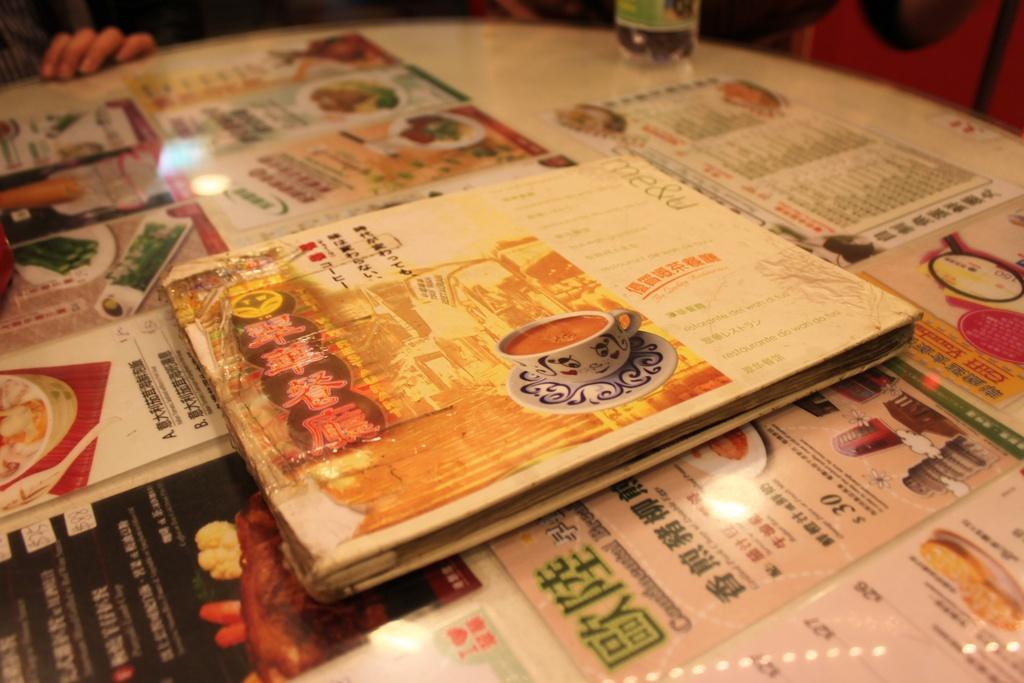<image>
Relay a brief, clear account of the picture shown. Food menu on a table with a dish that costs $26. 